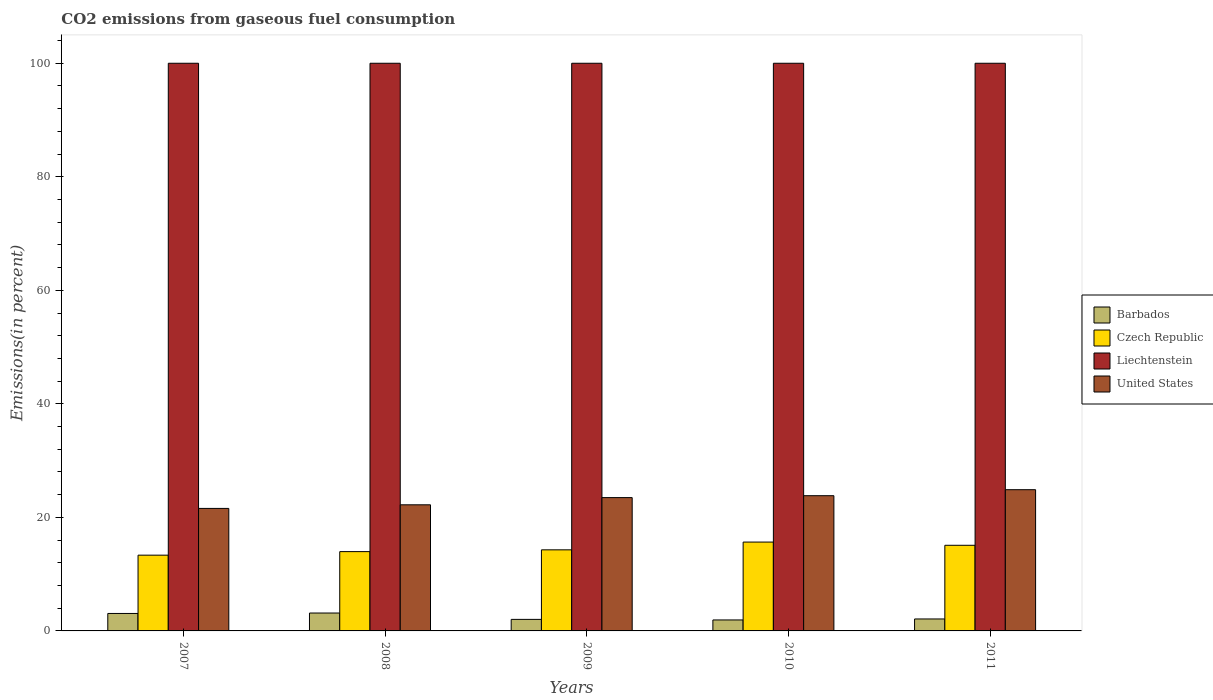How many groups of bars are there?
Keep it short and to the point. 5. Are the number of bars on each tick of the X-axis equal?
Offer a terse response. Yes. How many bars are there on the 4th tick from the left?
Offer a terse response. 4. What is the label of the 1st group of bars from the left?
Provide a succinct answer. 2007. What is the total CO2 emitted in Liechtenstein in 2008?
Ensure brevity in your answer.  100. Across all years, what is the minimum total CO2 emitted in United States?
Your response must be concise. 21.58. In which year was the total CO2 emitted in Liechtenstein maximum?
Your answer should be compact. 2007. In which year was the total CO2 emitted in United States minimum?
Offer a very short reply. 2007. What is the difference between the total CO2 emitted in United States in 2008 and that in 2011?
Provide a succinct answer. -2.66. What is the difference between the total CO2 emitted in Czech Republic in 2007 and the total CO2 emitted in Barbados in 2010?
Ensure brevity in your answer.  11.41. What is the average total CO2 emitted in United States per year?
Your response must be concise. 23.2. In the year 2009, what is the difference between the total CO2 emitted in United States and total CO2 emitted in Barbados?
Your response must be concise. 21.45. In how many years, is the total CO2 emitted in Liechtenstein greater than 20 %?
Ensure brevity in your answer.  5. What is the ratio of the total CO2 emitted in Czech Republic in 2010 to that in 2011?
Provide a short and direct response. 1.04. Is the total CO2 emitted in Czech Republic in 2007 less than that in 2011?
Your answer should be very brief. Yes. What is the difference between the highest and the second highest total CO2 emitted in Liechtenstein?
Offer a very short reply. 0. What is the difference between the highest and the lowest total CO2 emitted in Barbados?
Your response must be concise. 1.22. In how many years, is the total CO2 emitted in Barbados greater than the average total CO2 emitted in Barbados taken over all years?
Offer a very short reply. 2. Is the sum of the total CO2 emitted in Barbados in 2008 and 2010 greater than the maximum total CO2 emitted in United States across all years?
Your answer should be very brief. No. What does the 4th bar from the left in 2010 represents?
Your response must be concise. United States. What does the 2nd bar from the right in 2009 represents?
Provide a succinct answer. Liechtenstein. Is it the case that in every year, the sum of the total CO2 emitted in Czech Republic and total CO2 emitted in Barbados is greater than the total CO2 emitted in Liechtenstein?
Provide a succinct answer. No. Are the values on the major ticks of Y-axis written in scientific E-notation?
Offer a very short reply. No. Does the graph contain grids?
Your answer should be very brief. No. Where does the legend appear in the graph?
Give a very brief answer. Center right. How many legend labels are there?
Ensure brevity in your answer.  4. What is the title of the graph?
Give a very brief answer. CO2 emissions from gaseous fuel consumption. Does "Grenada" appear as one of the legend labels in the graph?
Ensure brevity in your answer.  No. What is the label or title of the Y-axis?
Provide a succinct answer. Emissions(in percent). What is the Emissions(in percent) of Barbados in 2007?
Your answer should be compact. 3.08. What is the Emissions(in percent) in Czech Republic in 2007?
Provide a short and direct response. 13.35. What is the Emissions(in percent) of Liechtenstein in 2007?
Offer a very short reply. 100. What is the Emissions(in percent) in United States in 2007?
Give a very brief answer. 21.58. What is the Emissions(in percent) of Barbados in 2008?
Your response must be concise. 3.15. What is the Emissions(in percent) of Czech Republic in 2008?
Provide a succinct answer. 13.97. What is the Emissions(in percent) in Liechtenstein in 2008?
Offer a very short reply. 100. What is the Emissions(in percent) of United States in 2008?
Make the answer very short. 22.22. What is the Emissions(in percent) in Barbados in 2009?
Offer a very short reply. 2.03. What is the Emissions(in percent) of Czech Republic in 2009?
Ensure brevity in your answer.  14.28. What is the Emissions(in percent) of Liechtenstein in 2009?
Make the answer very short. 100. What is the Emissions(in percent) in United States in 2009?
Give a very brief answer. 23.48. What is the Emissions(in percent) of Barbados in 2010?
Give a very brief answer. 1.93. What is the Emissions(in percent) in Czech Republic in 2010?
Make the answer very short. 15.65. What is the Emissions(in percent) of United States in 2010?
Make the answer very short. 23.82. What is the Emissions(in percent) in Barbados in 2011?
Offer a terse response. 2.11. What is the Emissions(in percent) in Czech Republic in 2011?
Offer a very short reply. 15.09. What is the Emissions(in percent) of United States in 2011?
Your response must be concise. 24.88. Across all years, what is the maximum Emissions(in percent) in Barbados?
Provide a succinct answer. 3.15. Across all years, what is the maximum Emissions(in percent) of Czech Republic?
Your answer should be very brief. 15.65. Across all years, what is the maximum Emissions(in percent) of Liechtenstein?
Provide a short and direct response. 100. Across all years, what is the maximum Emissions(in percent) of United States?
Your answer should be very brief. 24.88. Across all years, what is the minimum Emissions(in percent) of Barbados?
Your answer should be compact. 1.93. Across all years, what is the minimum Emissions(in percent) of Czech Republic?
Offer a very short reply. 13.35. Across all years, what is the minimum Emissions(in percent) in United States?
Provide a short and direct response. 21.58. What is the total Emissions(in percent) in Barbados in the graph?
Your answer should be very brief. 12.3. What is the total Emissions(in percent) in Czech Republic in the graph?
Make the answer very short. 72.34. What is the total Emissions(in percent) of United States in the graph?
Offer a very short reply. 115.98. What is the difference between the Emissions(in percent) of Barbados in 2007 and that in 2008?
Give a very brief answer. -0.08. What is the difference between the Emissions(in percent) of Czech Republic in 2007 and that in 2008?
Offer a very short reply. -0.63. What is the difference between the Emissions(in percent) of United States in 2007 and that in 2008?
Provide a succinct answer. -0.64. What is the difference between the Emissions(in percent) of Barbados in 2007 and that in 2009?
Offer a very short reply. 1.05. What is the difference between the Emissions(in percent) in Czech Republic in 2007 and that in 2009?
Ensure brevity in your answer.  -0.94. What is the difference between the Emissions(in percent) of United States in 2007 and that in 2009?
Your response must be concise. -1.9. What is the difference between the Emissions(in percent) of Barbados in 2007 and that in 2010?
Offer a terse response. 1.14. What is the difference between the Emissions(in percent) of Czech Republic in 2007 and that in 2010?
Provide a short and direct response. -2.31. What is the difference between the Emissions(in percent) of Liechtenstein in 2007 and that in 2010?
Provide a succinct answer. 0. What is the difference between the Emissions(in percent) of United States in 2007 and that in 2010?
Make the answer very short. -2.24. What is the difference between the Emissions(in percent) in Barbados in 2007 and that in 2011?
Provide a short and direct response. 0.97. What is the difference between the Emissions(in percent) of Czech Republic in 2007 and that in 2011?
Your answer should be very brief. -1.74. What is the difference between the Emissions(in percent) of Liechtenstein in 2007 and that in 2011?
Make the answer very short. 0. What is the difference between the Emissions(in percent) of United States in 2007 and that in 2011?
Make the answer very short. -3.3. What is the difference between the Emissions(in percent) in Barbados in 2008 and that in 2009?
Offer a very short reply. 1.12. What is the difference between the Emissions(in percent) in Czech Republic in 2008 and that in 2009?
Your response must be concise. -0.31. What is the difference between the Emissions(in percent) of United States in 2008 and that in 2009?
Provide a succinct answer. -1.27. What is the difference between the Emissions(in percent) of Barbados in 2008 and that in 2010?
Offer a terse response. 1.22. What is the difference between the Emissions(in percent) in Czech Republic in 2008 and that in 2010?
Your answer should be very brief. -1.68. What is the difference between the Emissions(in percent) in United States in 2008 and that in 2010?
Make the answer very short. -1.6. What is the difference between the Emissions(in percent) of Barbados in 2008 and that in 2011?
Provide a short and direct response. 1.05. What is the difference between the Emissions(in percent) in Czech Republic in 2008 and that in 2011?
Provide a succinct answer. -1.11. What is the difference between the Emissions(in percent) of United States in 2008 and that in 2011?
Provide a succinct answer. -2.66. What is the difference between the Emissions(in percent) in Barbados in 2009 and that in 2010?
Your answer should be very brief. 0.1. What is the difference between the Emissions(in percent) in Czech Republic in 2009 and that in 2010?
Your answer should be compact. -1.37. What is the difference between the Emissions(in percent) of Liechtenstein in 2009 and that in 2010?
Give a very brief answer. 0. What is the difference between the Emissions(in percent) of United States in 2009 and that in 2010?
Ensure brevity in your answer.  -0.34. What is the difference between the Emissions(in percent) of Barbados in 2009 and that in 2011?
Keep it short and to the point. -0.08. What is the difference between the Emissions(in percent) of Czech Republic in 2009 and that in 2011?
Give a very brief answer. -0.8. What is the difference between the Emissions(in percent) in United States in 2009 and that in 2011?
Offer a terse response. -1.39. What is the difference between the Emissions(in percent) of Barbados in 2010 and that in 2011?
Offer a terse response. -0.18. What is the difference between the Emissions(in percent) of Czech Republic in 2010 and that in 2011?
Provide a short and direct response. 0.57. What is the difference between the Emissions(in percent) in United States in 2010 and that in 2011?
Keep it short and to the point. -1.06. What is the difference between the Emissions(in percent) in Barbados in 2007 and the Emissions(in percent) in Czech Republic in 2008?
Keep it short and to the point. -10.89. What is the difference between the Emissions(in percent) of Barbados in 2007 and the Emissions(in percent) of Liechtenstein in 2008?
Your response must be concise. -96.92. What is the difference between the Emissions(in percent) of Barbados in 2007 and the Emissions(in percent) of United States in 2008?
Keep it short and to the point. -19.14. What is the difference between the Emissions(in percent) of Czech Republic in 2007 and the Emissions(in percent) of Liechtenstein in 2008?
Ensure brevity in your answer.  -86.65. What is the difference between the Emissions(in percent) in Czech Republic in 2007 and the Emissions(in percent) in United States in 2008?
Provide a short and direct response. -8.87. What is the difference between the Emissions(in percent) in Liechtenstein in 2007 and the Emissions(in percent) in United States in 2008?
Provide a succinct answer. 77.78. What is the difference between the Emissions(in percent) of Barbados in 2007 and the Emissions(in percent) of Czech Republic in 2009?
Keep it short and to the point. -11.21. What is the difference between the Emissions(in percent) in Barbados in 2007 and the Emissions(in percent) in Liechtenstein in 2009?
Keep it short and to the point. -96.92. What is the difference between the Emissions(in percent) of Barbados in 2007 and the Emissions(in percent) of United States in 2009?
Offer a very short reply. -20.41. What is the difference between the Emissions(in percent) in Czech Republic in 2007 and the Emissions(in percent) in Liechtenstein in 2009?
Ensure brevity in your answer.  -86.65. What is the difference between the Emissions(in percent) of Czech Republic in 2007 and the Emissions(in percent) of United States in 2009?
Ensure brevity in your answer.  -10.14. What is the difference between the Emissions(in percent) of Liechtenstein in 2007 and the Emissions(in percent) of United States in 2009?
Give a very brief answer. 76.52. What is the difference between the Emissions(in percent) of Barbados in 2007 and the Emissions(in percent) of Czech Republic in 2010?
Give a very brief answer. -12.57. What is the difference between the Emissions(in percent) in Barbados in 2007 and the Emissions(in percent) in Liechtenstein in 2010?
Your response must be concise. -96.92. What is the difference between the Emissions(in percent) in Barbados in 2007 and the Emissions(in percent) in United States in 2010?
Offer a very short reply. -20.74. What is the difference between the Emissions(in percent) in Czech Republic in 2007 and the Emissions(in percent) in Liechtenstein in 2010?
Provide a succinct answer. -86.65. What is the difference between the Emissions(in percent) of Czech Republic in 2007 and the Emissions(in percent) of United States in 2010?
Make the answer very short. -10.48. What is the difference between the Emissions(in percent) of Liechtenstein in 2007 and the Emissions(in percent) of United States in 2010?
Offer a very short reply. 76.18. What is the difference between the Emissions(in percent) in Barbados in 2007 and the Emissions(in percent) in Czech Republic in 2011?
Your answer should be very brief. -12.01. What is the difference between the Emissions(in percent) in Barbados in 2007 and the Emissions(in percent) in Liechtenstein in 2011?
Your response must be concise. -96.92. What is the difference between the Emissions(in percent) of Barbados in 2007 and the Emissions(in percent) of United States in 2011?
Offer a terse response. -21.8. What is the difference between the Emissions(in percent) of Czech Republic in 2007 and the Emissions(in percent) of Liechtenstein in 2011?
Give a very brief answer. -86.65. What is the difference between the Emissions(in percent) of Czech Republic in 2007 and the Emissions(in percent) of United States in 2011?
Provide a succinct answer. -11.53. What is the difference between the Emissions(in percent) of Liechtenstein in 2007 and the Emissions(in percent) of United States in 2011?
Make the answer very short. 75.12. What is the difference between the Emissions(in percent) of Barbados in 2008 and the Emissions(in percent) of Czech Republic in 2009?
Give a very brief answer. -11.13. What is the difference between the Emissions(in percent) of Barbados in 2008 and the Emissions(in percent) of Liechtenstein in 2009?
Provide a succinct answer. -96.85. What is the difference between the Emissions(in percent) in Barbados in 2008 and the Emissions(in percent) in United States in 2009?
Your response must be concise. -20.33. What is the difference between the Emissions(in percent) in Czech Republic in 2008 and the Emissions(in percent) in Liechtenstein in 2009?
Provide a short and direct response. -86.03. What is the difference between the Emissions(in percent) of Czech Republic in 2008 and the Emissions(in percent) of United States in 2009?
Keep it short and to the point. -9.51. What is the difference between the Emissions(in percent) of Liechtenstein in 2008 and the Emissions(in percent) of United States in 2009?
Provide a succinct answer. 76.52. What is the difference between the Emissions(in percent) in Barbados in 2008 and the Emissions(in percent) in Czech Republic in 2010?
Your answer should be compact. -12.5. What is the difference between the Emissions(in percent) of Barbados in 2008 and the Emissions(in percent) of Liechtenstein in 2010?
Your answer should be very brief. -96.85. What is the difference between the Emissions(in percent) of Barbados in 2008 and the Emissions(in percent) of United States in 2010?
Offer a terse response. -20.67. What is the difference between the Emissions(in percent) of Czech Republic in 2008 and the Emissions(in percent) of Liechtenstein in 2010?
Your response must be concise. -86.03. What is the difference between the Emissions(in percent) of Czech Republic in 2008 and the Emissions(in percent) of United States in 2010?
Offer a very short reply. -9.85. What is the difference between the Emissions(in percent) of Liechtenstein in 2008 and the Emissions(in percent) of United States in 2010?
Provide a short and direct response. 76.18. What is the difference between the Emissions(in percent) in Barbados in 2008 and the Emissions(in percent) in Czech Republic in 2011?
Provide a succinct answer. -11.93. What is the difference between the Emissions(in percent) of Barbados in 2008 and the Emissions(in percent) of Liechtenstein in 2011?
Your answer should be very brief. -96.85. What is the difference between the Emissions(in percent) of Barbados in 2008 and the Emissions(in percent) of United States in 2011?
Your response must be concise. -21.73. What is the difference between the Emissions(in percent) in Czech Republic in 2008 and the Emissions(in percent) in Liechtenstein in 2011?
Provide a short and direct response. -86.03. What is the difference between the Emissions(in percent) of Czech Republic in 2008 and the Emissions(in percent) of United States in 2011?
Your answer should be compact. -10.91. What is the difference between the Emissions(in percent) in Liechtenstein in 2008 and the Emissions(in percent) in United States in 2011?
Your answer should be very brief. 75.12. What is the difference between the Emissions(in percent) of Barbados in 2009 and the Emissions(in percent) of Czech Republic in 2010?
Your response must be concise. -13.62. What is the difference between the Emissions(in percent) in Barbados in 2009 and the Emissions(in percent) in Liechtenstein in 2010?
Make the answer very short. -97.97. What is the difference between the Emissions(in percent) in Barbados in 2009 and the Emissions(in percent) in United States in 2010?
Make the answer very short. -21.79. What is the difference between the Emissions(in percent) in Czech Republic in 2009 and the Emissions(in percent) in Liechtenstein in 2010?
Provide a short and direct response. -85.72. What is the difference between the Emissions(in percent) in Czech Republic in 2009 and the Emissions(in percent) in United States in 2010?
Ensure brevity in your answer.  -9.54. What is the difference between the Emissions(in percent) of Liechtenstein in 2009 and the Emissions(in percent) of United States in 2010?
Make the answer very short. 76.18. What is the difference between the Emissions(in percent) in Barbados in 2009 and the Emissions(in percent) in Czech Republic in 2011?
Your response must be concise. -13.05. What is the difference between the Emissions(in percent) in Barbados in 2009 and the Emissions(in percent) in Liechtenstein in 2011?
Give a very brief answer. -97.97. What is the difference between the Emissions(in percent) in Barbados in 2009 and the Emissions(in percent) in United States in 2011?
Give a very brief answer. -22.85. What is the difference between the Emissions(in percent) in Czech Republic in 2009 and the Emissions(in percent) in Liechtenstein in 2011?
Provide a short and direct response. -85.72. What is the difference between the Emissions(in percent) in Czech Republic in 2009 and the Emissions(in percent) in United States in 2011?
Ensure brevity in your answer.  -10.6. What is the difference between the Emissions(in percent) in Liechtenstein in 2009 and the Emissions(in percent) in United States in 2011?
Provide a short and direct response. 75.12. What is the difference between the Emissions(in percent) in Barbados in 2010 and the Emissions(in percent) in Czech Republic in 2011?
Ensure brevity in your answer.  -13.15. What is the difference between the Emissions(in percent) of Barbados in 2010 and the Emissions(in percent) of Liechtenstein in 2011?
Provide a short and direct response. -98.07. What is the difference between the Emissions(in percent) in Barbados in 2010 and the Emissions(in percent) in United States in 2011?
Your answer should be very brief. -22.95. What is the difference between the Emissions(in percent) of Czech Republic in 2010 and the Emissions(in percent) of Liechtenstein in 2011?
Your response must be concise. -84.35. What is the difference between the Emissions(in percent) of Czech Republic in 2010 and the Emissions(in percent) of United States in 2011?
Provide a succinct answer. -9.23. What is the difference between the Emissions(in percent) in Liechtenstein in 2010 and the Emissions(in percent) in United States in 2011?
Provide a succinct answer. 75.12. What is the average Emissions(in percent) in Barbados per year?
Keep it short and to the point. 2.46. What is the average Emissions(in percent) of Czech Republic per year?
Your response must be concise. 14.47. What is the average Emissions(in percent) of United States per year?
Your answer should be compact. 23.2. In the year 2007, what is the difference between the Emissions(in percent) in Barbados and Emissions(in percent) in Czech Republic?
Give a very brief answer. -10.27. In the year 2007, what is the difference between the Emissions(in percent) of Barbados and Emissions(in percent) of Liechtenstein?
Provide a succinct answer. -96.92. In the year 2007, what is the difference between the Emissions(in percent) in Barbados and Emissions(in percent) in United States?
Your response must be concise. -18.5. In the year 2007, what is the difference between the Emissions(in percent) in Czech Republic and Emissions(in percent) in Liechtenstein?
Your response must be concise. -86.65. In the year 2007, what is the difference between the Emissions(in percent) of Czech Republic and Emissions(in percent) of United States?
Provide a short and direct response. -8.24. In the year 2007, what is the difference between the Emissions(in percent) of Liechtenstein and Emissions(in percent) of United States?
Give a very brief answer. 78.42. In the year 2008, what is the difference between the Emissions(in percent) in Barbados and Emissions(in percent) in Czech Republic?
Your answer should be compact. -10.82. In the year 2008, what is the difference between the Emissions(in percent) of Barbados and Emissions(in percent) of Liechtenstein?
Ensure brevity in your answer.  -96.85. In the year 2008, what is the difference between the Emissions(in percent) of Barbados and Emissions(in percent) of United States?
Offer a terse response. -19.06. In the year 2008, what is the difference between the Emissions(in percent) of Czech Republic and Emissions(in percent) of Liechtenstein?
Your answer should be compact. -86.03. In the year 2008, what is the difference between the Emissions(in percent) in Czech Republic and Emissions(in percent) in United States?
Give a very brief answer. -8.25. In the year 2008, what is the difference between the Emissions(in percent) in Liechtenstein and Emissions(in percent) in United States?
Make the answer very short. 77.78. In the year 2009, what is the difference between the Emissions(in percent) in Barbados and Emissions(in percent) in Czech Republic?
Your response must be concise. -12.25. In the year 2009, what is the difference between the Emissions(in percent) of Barbados and Emissions(in percent) of Liechtenstein?
Offer a terse response. -97.97. In the year 2009, what is the difference between the Emissions(in percent) of Barbados and Emissions(in percent) of United States?
Give a very brief answer. -21.45. In the year 2009, what is the difference between the Emissions(in percent) in Czech Republic and Emissions(in percent) in Liechtenstein?
Offer a very short reply. -85.72. In the year 2009, what is the difference between the Emissions(in percent) of Czech Republic and Emissions(in percent) of United States?
Your response must be concise. -9.2. In the year 2009, what is the difference between the Emissions(in percent) of Liechtenstein and Emissions(in percent) of United States?
Offer a very short reply. 76.52. In the year 2010, what is the difference between the Emissions(in percent) of Barbados and Emissions(in percent) of Czech Republic?
Give a very brief answer. -13.72. In the year 2010, what is the difference between the Emissions(in percent) in Barbados and Emissions(in percent) in Liechtenstein?
Provide a short and direct response. -98.07. In the year 2010, what is the difference between the Emissions(in percent) of Barbados and Emissions(in percent) of United States?
Keep it short and to the point. -21.89. In the year 2010, what is the difference between the Emissions(in percent) of Czech Republic and Emissions(in percent) of Liechtenstein?
Your response must be concise. -84.35. In the year 2010, what is the difference between the Emissions(in percent) in Czech Republic and Emissions(in percent) in United States?
Provide a short and direct response. -8.17. In the year 2010, what is the difference between the Emissions(in percent) in Liechtenstein and Emissions(in percent) in United States?
Give a very brief answer. 76.18. In the year 2011, what is the difference between the Emissions(in percent) of Barbados and Emissions(in percent) of Czech Republic?
Keep it short and to the point. -12.98. In the year 2011, what is the difference between the Emissions(in percent) of Barbados and Emissions(in percent) of Liechtenstein?
Provide a succinct answer. -97.89. In the year 2011, what is the difference between the Emissions(in percent) of Barbados and Emissions(in percent) of United States?
Your response must be concise. -22.77. In the year 2011, what is the difference between the Emissions(in percent) in Czech Republic and Emissions(in percent) in Liechtenstein?
Ensure brevity in your answer.  -84.91. In the year 2011, what is the difference between the Emissions(in percent) of Czech Republic and Emissions(in percent) of United States?
Offer a terse response. -9.79. In the year 2011, what is the difference between the Emissions(in percent) of Liechtenstein and Emissions(in percent) of United States?
Keep it short and to the point. 75.12. What is the ratio of the Emissions(in percent) of Barbados in 2007 to that in 2008?
Provide a succinct answer. 0.98. What is the ratio of the Emissions(in percent) in Czech Republic in 2007 to that in 2008?
Your answer should be compact. 0.96. What is the ratio of the Emissions(in percent) of United States in 2007 to that in 2008?
Give a very brief answer. 0.97. What is the ratio of the Emissions(in percent) in Barbados in 2007 to that in 2009?
Provide a succinct answer. 1.51. What is the ratio of the Emissions(in percent) in Czech Republic in 2007 to that in 2009?
Make the answer very short. 0.93. What is the ratio of the Emissions(in percent) in United States in 2007 to that in 2009?
Offer a terse response. 0.92. What is the ratio of the Emissions(in percent) in Barbados in 2007 to that in 2010?
Provide a short and direct response. 1.59. What is the ratio of the Emissions(in percent) of Czech Republic in 2007 to that in 2010?
Provide a succinct answer. 0.85. What is the ratio of the Emissions(in percent) of Liechtenstein in 2007 to that in 2010?
Offer a very short reply. 1. What is the ratio of the Emissions(in percent) in United States in 2007 to that in 2010?
Ensure brevity in your answer.  0.91. What is the ratio of the Emissions(in percent) of Barbados in 2007 to that in 2011?
Provide a short and direct response. 1.46. What is the ratio of the Emissions(in percent) of Czech Republic in 2007 to that in 2011?
Your answer should be very brief. 0.88. What is the ratio of the Emissions(in percent) of Liechtenstein in 2007 to that in 2011?
Your response must be concise. 1. What is the ratio of the Emissions(in percent) in United States in 2007 to that in 2011?
Provide a succinct answer. 0.87. What is the ratio of the Emissions(in percent) in Barbados in 2008 to that in 2009?
Ensure brevity in your answer.  1.55. What is the ratio of the Emissions(in percent) of Czech Republic in 2008 to that in 2009?
Offer a very short reply. 0.98. What is the ratio of the Emissions(in percent) in Liechtenstein in 2008 to that in 2009?
Keep it short and to the point. 1. What is the ratio of the Emissions(in percent) in United States in 2008 to that in 2009?
Make the answer very short. 0.95. What is the ratio of the Emissions(in percent) in Barbados in 2008 to that in 2010?
Your answer should be very brief. 1.63. What is the ratio of the Emissions(in percent) of Czech Republic in 2008 to that in 2010?
Your answer should be compact. 0.89. What is the ratio of the Emissions(in percent) in United States in 2008 to that in 2010?
Provide a short and direct response. 0.93. What is the ratio of the Emissions(in percent) of Barbados in 2008 to that in 2011?
Give a very brief answer. 1.5. What is the ratio of the Emissions(in percent) in Czech Republic in 2008 to that in 2011?
Offer a terse response. 0.93. What is the ratio of the Emissions(in percent) of United States in 2008 to that in 2011?
Ensure brevity in your answer.  0.89. What is the ratio of the Emissions(in percent) of Barbados in 2009 to that in 2010?
Your response must be concise. 1.05. What is the ratio of the Emissions(in percent) in Czech Republic in 2009 to that in 2010?
Provide a short and direct response. 0.91. What is the ratio of the Emissions(in percent) of United States in 2009 to that in 2010?
Give a very brief answer. 0.99. What is the ratio of the Emissions(in percent) in Barbados in 2009 to that in 2011?
Ensure brevity in your answer.  0.96. What is the ratio of the Emissions(in percent) of Czech Republic in 2009 to that in 2011?
Give a very brief answer. 0.95. What is the ratio of the Emissions(in percent) of Liechtenstein in 2009 to that in 2011?
Provide a succinct answer. 1. What is the ratio of the Emissions(in percent) of United States in 2009 to that in 2011?
Your answer should be compact. 0.94. What is the ratio of the Emissions(in percent) in Barbados in 2010 to that in 2011?
Keep it short and to the point. 0.92. What is the ratio of the Emissions(in percent) of Czech Republic in 2010 to that in 2011?
Give a very brief answer. 1.04. What is the ratio of the Emissions(in percent) in United States in 2010 to that in 2011?
Provide a succinct answer. 0.96. What is the difference between the highest and the second highest Emissions(in percent) of Barbados?
Keep it short and to the point. 0.08. What is the difference between the highest and the second highest Emissions(in percent) in Czech Republic?
Offer a very short reply. 0.57. What is the difference between the highest and the second highest Emissions(in percent) in Liechtenstein?
Provide a short and direct response. 0. What is the difference between the highest and the second highest Emissions(in percent) of United States?
Make the answer very short. 1.06. What is the difference between the highest and the lowest Emissions(in percent) in Barbados?
Offer a terse response. 1.22. What is the difference between the highest and the lowest Emissions(in percent) of Czech Republic?
Ensure brevity in your answer.  2.31. What is the difference between the highest and the lowest Emissions(in percent) of Liechtenstein?
Give a very brief answer. 0. What is the difference between the highest and the lowest Emissions(in percent) in United States?
Give a very brief answer. 3.3. 